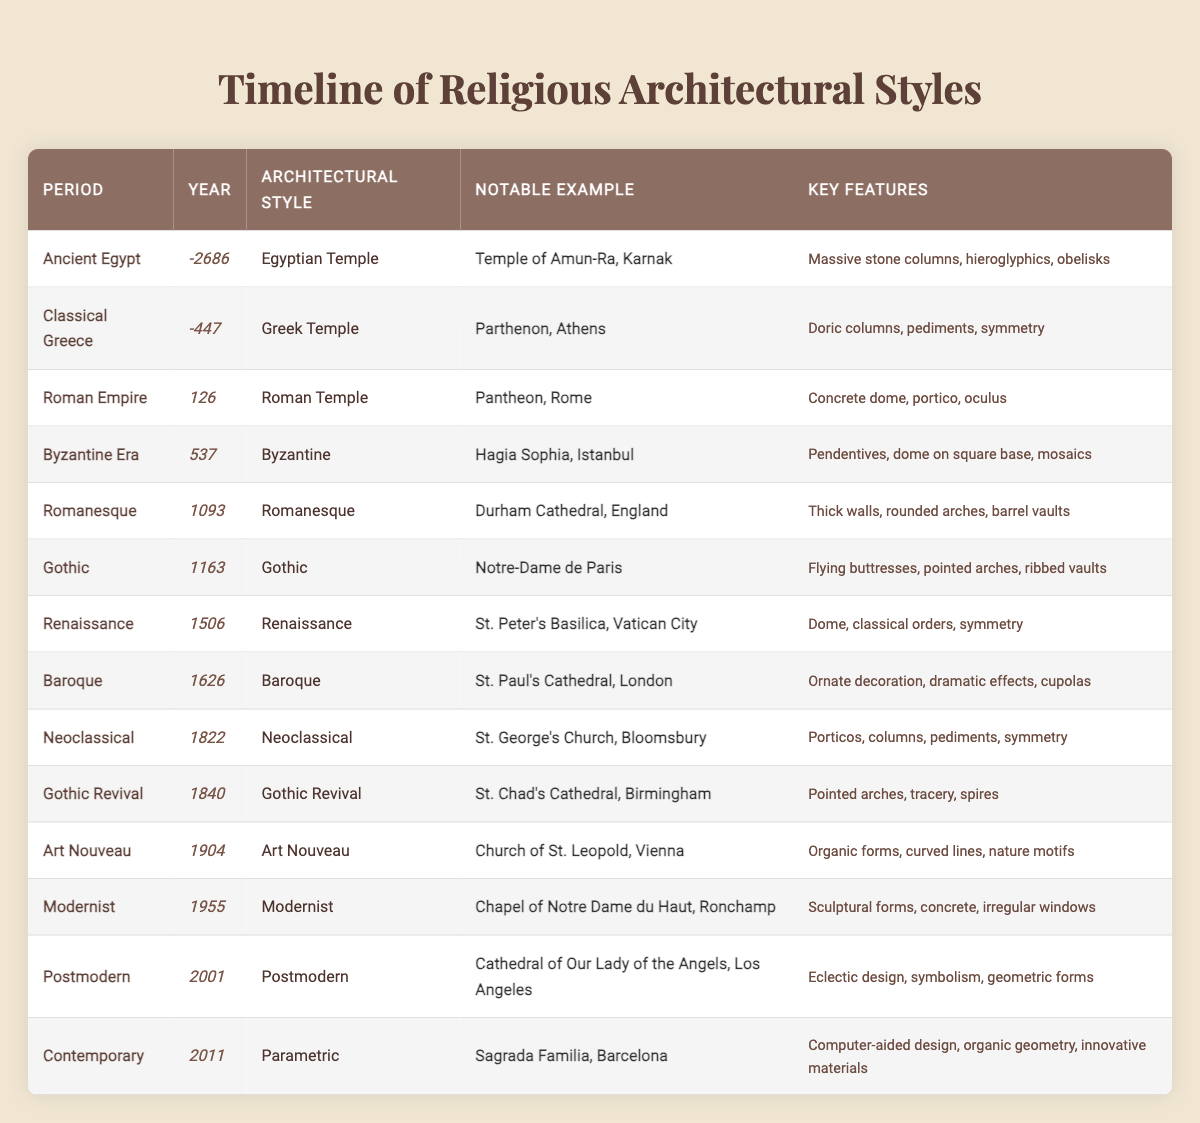What architectural style is associated with the year 126? The year 126 corresponds to the Roman Empire period in the table, and its associated architectural style is the Roman Temple.
Answer: Roman Temple Which notable example is listed under the Gothic architectural style? The Gothic architectural style has Notre-Dame de Paris as its notable example in the table.
Answer: Notre-Dame de Paris How many architectural styles are classified before the Renaissance period? The table lists 6 architectural styles before the Renaissance: Egyptian Temple, Greek Temple, Roman Temple, Byzantine, Romanesque, and Gothic. Therefore, the count is 6.
Answer: 6 What are the key features of the Byzantine architectural style? The key features listed for the Byzantine architectural style are pendentives, a dome on a square base, and mosaics.
Answer: Pendentives, dome on square base, mosaics Is St. Chad's Cathedral associated with the Gothic Revival style? Yes, St. Chad's Cathedral is specified as a notable example of the Gothic Revival architectural style in the table.
Answer: Yes Which architectural style includes the use of flying buttresses? The Gothic architectural style is noted for its use of flying buttresses according to the information in the table.
Answer: Gothic How many examples are there with "dome" as a key feature? In the table, there are two examples with "dome" as a key feature: Hagia Sophia and St. Peter's Basilica. Therefore, the count is 2.
Answer: 2 What is the relationship between the Romanesque and Gothic periods in terms of years? The Romanesque period is from 1093 to the Gothic period starting in 1163, marking a 70-year span. Thus, the difference in years is 70.
Answer: 70 years Does the table provide any architectural styles that only emerged after the year 2000? Yes, the table lists one architectural style after 2000, which is Postmodern in 2001.
Answer: Yes What notable structures are exemplars of the Neoclassical and Baroque styles, respectively? The notable example for Neoclassical is St. George's Church, and for Baroque, it is St. Paul's Cathedral according to the table.
Answer: St. George's Church; St. Paul's Cathedral Which architectural style features organic forms and nature motifs? The Art Nouveau architectural style is characterized by organic forms, curved lines, and nature motifs as specified in the table.
Answer: Art Nouveau What can you infer about the evolution of architectural styles from ancient to contemporary based on the table? The table shows a progression of architectural styles, starting from ancient Egyptian structures and culminating in contemporary parametric designs, indicating a significant evolution in design principles and techniques over time.
Answer: Evolution from ancient Egyptian to contemporary styles 